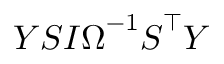<formula> <loc_0><loc_0><loc_500><loc_500>Y S I \Omega ^ { - 1 } S ^ { \intercal } Y</formula> 